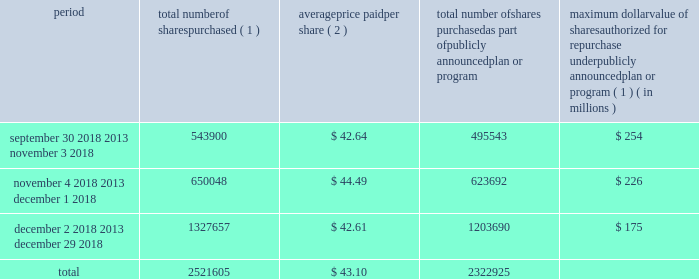Issuer purchases of equity securities in january 2017 , our board of directors authorized the repurchase of shares of our common stock with a value of up to $ 525 million in the aggregate .
As of december 29 , 2018 , $ 175 million remained available under this authorization .
In february 2019 , our board of directors authorized the additional repurchase of shares of our common stock with a value of up to $ 500.0 million in the aggregate .
The actual timing and amount of repurchases are subject to business and market conditions , corporate and regulatory requirements , stock price , acquisition opportunities and other factors .
The table presents repurchases made under our current authorization and shares surrendered by employees to satisfy income tax withholding obligations during the three months ended december 29 , 2018 : period total number of shares purchased ( 1 ) average price paid per share ( 2 ) total number of shares purchased as part of publicly announced plan or program maximum dollar value of shares authorized for repurchase under publicly announced plan or program ( 1 ) ( in millions ) september 30 , 2018 2013 november 3 , 2018 543900 $ 42.64 495543 $ 254 november 4 , 2018 2013 december 1 , 2018 650048 $ 44.49 623692 $ 226 december 2 , 2018 2013 december 29 , 2018 1327657 $ 42.61 1203690 $ 175 .
( 1 ) shares purchased that were not part of our publicly announced repurchase programs represent employee surrender of shares of restricted stock to satisfy employee income tax withholding obligations due upon vesting , and do not reduce the dollar value that may yet be purchased under our publicly announced repurchase programs .
( 2 ) the weighted average price paid per share of common stock does not include the cost of commissions. .
What was the average number of total number of shares purchased as part of publicly announced plan or program for the three monthly periods ending december 29 , 2018? 
Computations: (2322925 / 3)
Answer: 774308.33333. 